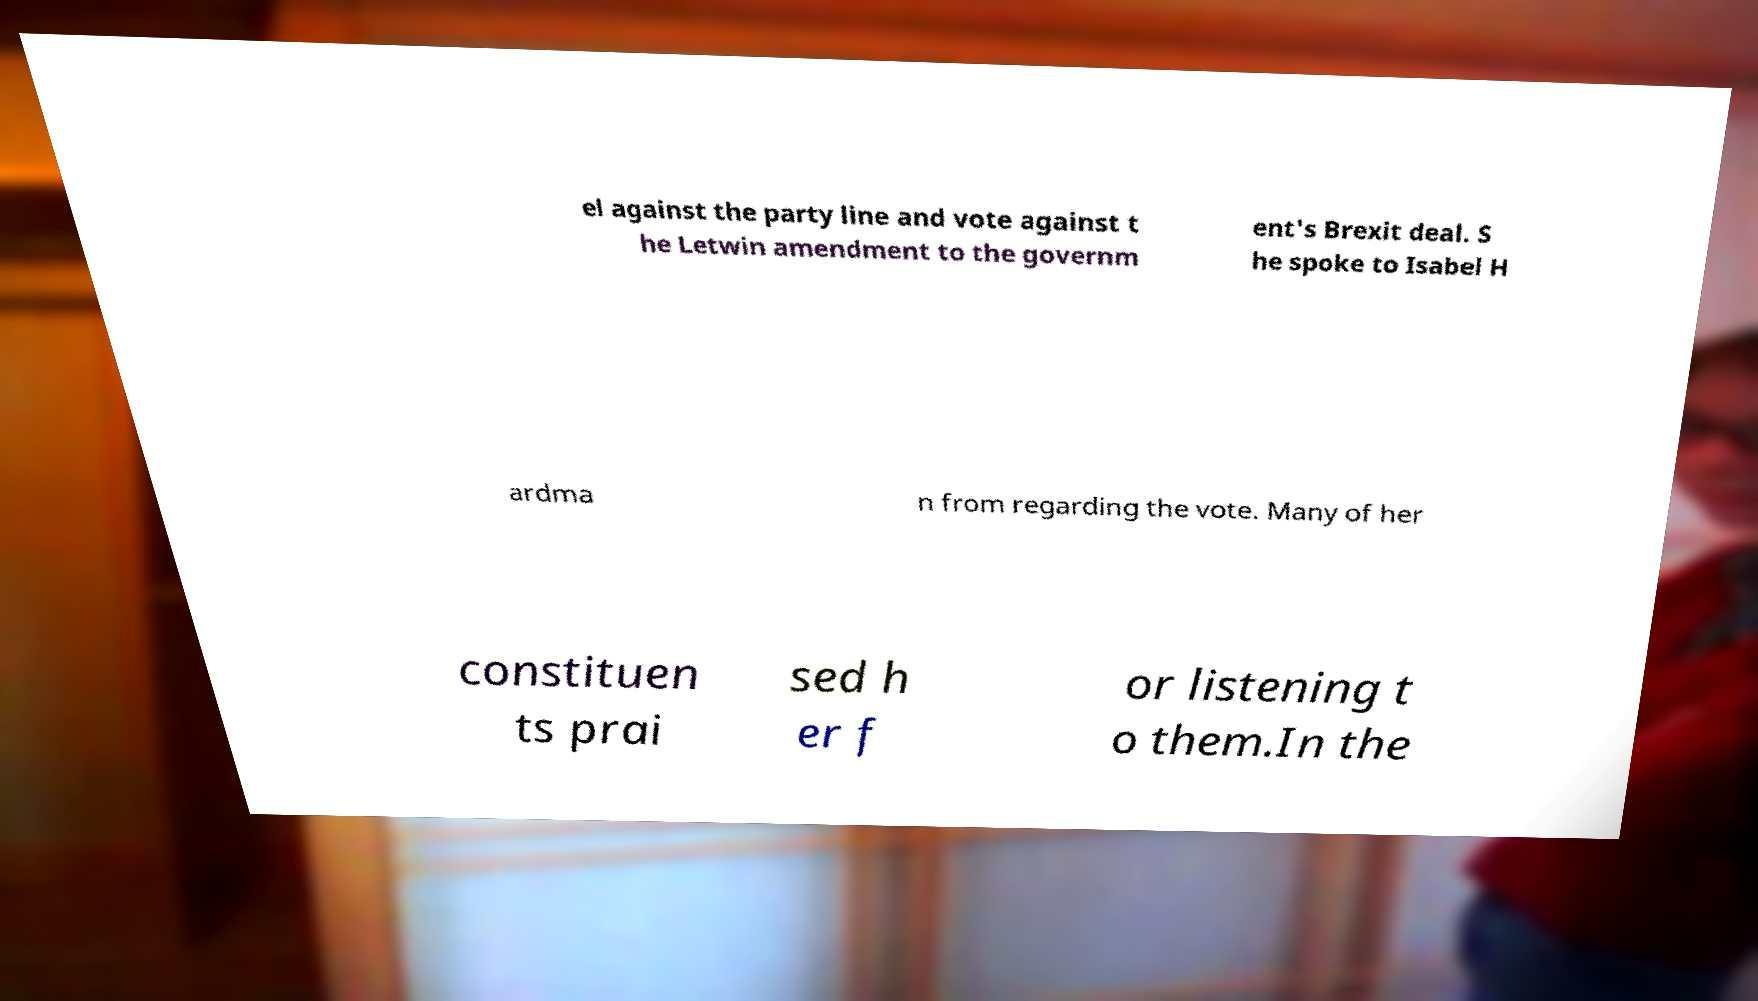What messages or text are displayed in this image? I need them in a readable, typed format. el against the party line and vote against t he Letwin amendment to the governm ent's Brexit deal. S he spoke to Isabel H ardma n from regarding the vote. Many of her constituen ts prai sed h er f or listening t o them.In the 